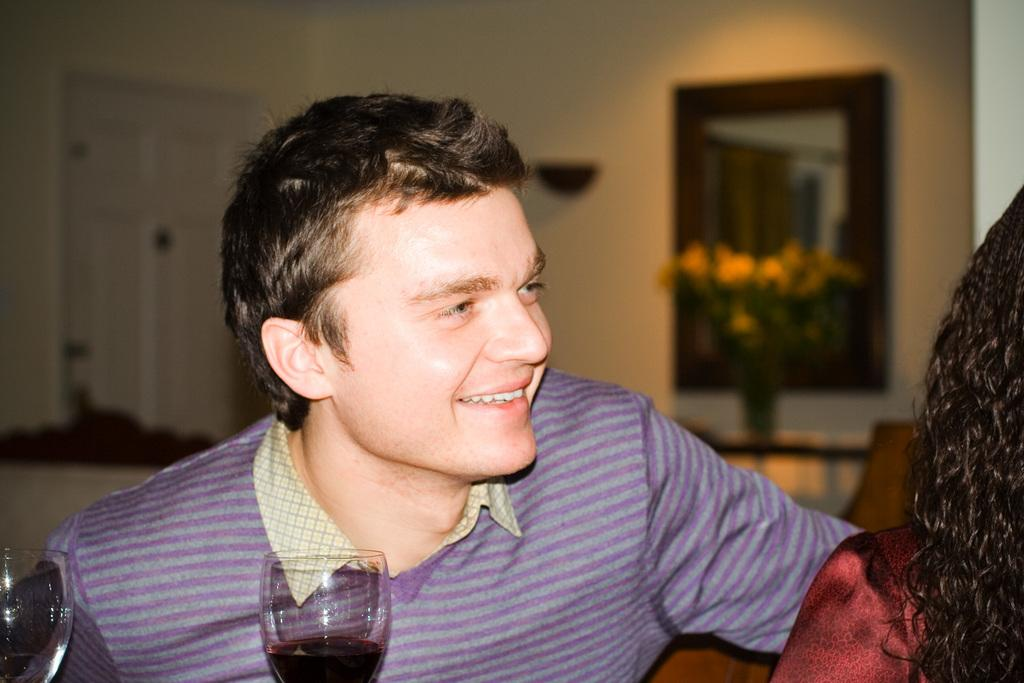How many people are sitting on the sofa in the image? There are two people sitting on the sofa in the image. What can be seen next to the sofa? There are two glasses with some drink. What architectural feature is present in the image? There is a door in the image. What decorative item is on the table? There is a flower vase on the table. What is attached to the wall in the image? There is a frame attached to the wall. Reasoning: Let's think step by step by step in order to produce the conversation. We start by identifying the main subjects and objects in the image based on the provided facts. We then formulate questions that focus on the location and characteristics of these subjects and objects, ensuring that each question can be answered definitively with the information given. We avoid yes/no questions and ensure that the language is simple and clear. Absurd Question/Answer: Can you tell me if the two people sitting on the sofa are having an argument in the image? There is no indication of an argument in the image; the two people are simply sitting on the sofa. Is there a yak present in the image? No, there is no yak present in the image. 